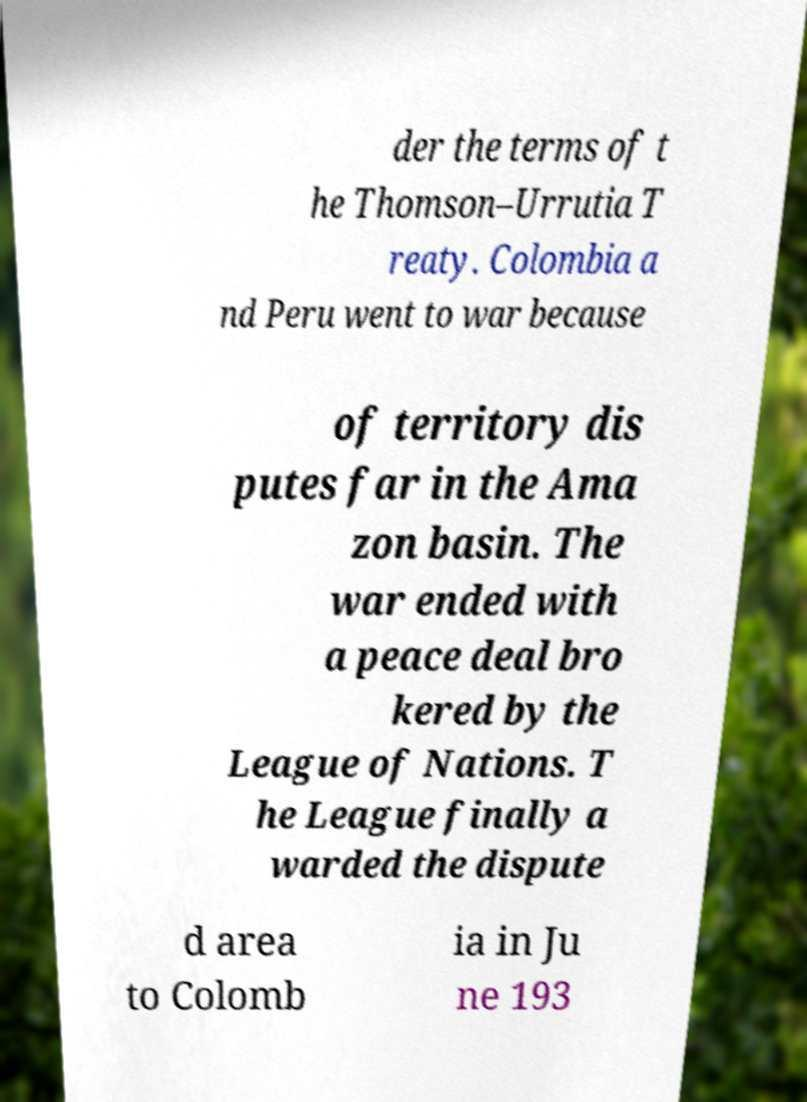For documentation purposes, I need the text within this image transcribed. Could you provide that? der the terms of t he Thomson–Urrutia T reaty. Colombia a nd Peru went to war because of territory dis putes far in the Ama zon basin. The war ended with a peace deal bro kered by the League of Nations. T he League finally a warded the dispute d area to Colomb ia in Ju ne 193 